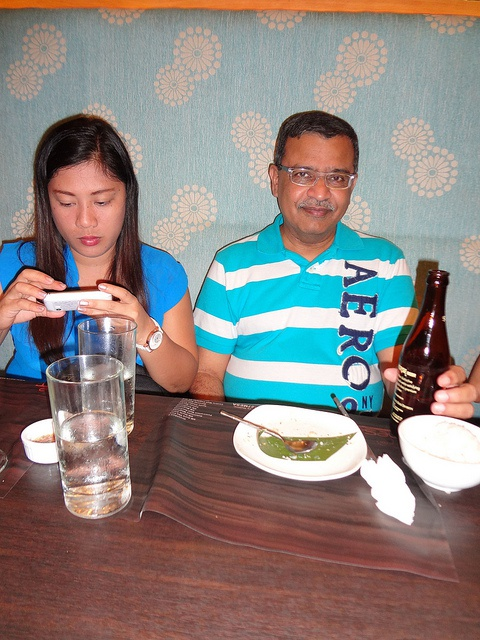Describe the objects in this image and their specific colors. I can see dining table in red, brown, maroon, and white tones, people in red, lightblue, white, and brown tones, people in red, black, salmon, gray, and brown tones, cup in red, darkgray, gray, and lightgray tones, and bottle in red, black, maroon, darkgray, and gray tones in this image. 